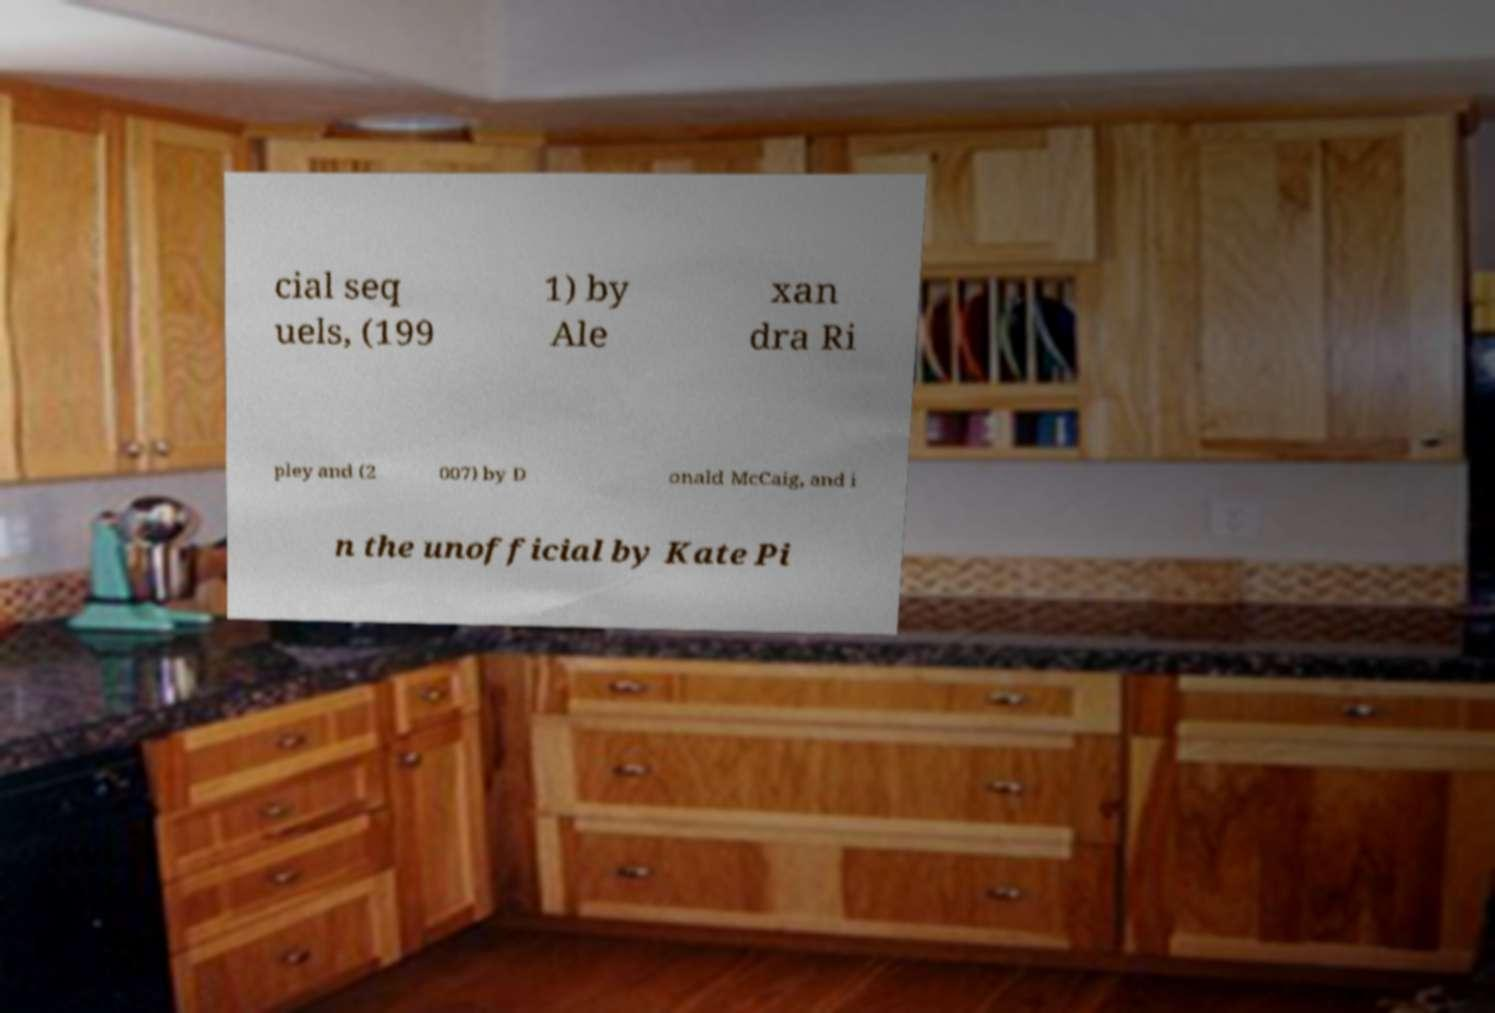For documentation purposes, I need the text within this image transcribed. Could you provide that? cial seq uels, (199 1) by Ale xan dra Ri pley and (2 007) by D onald McCaig, and i n the unofficial by Kate Pi 